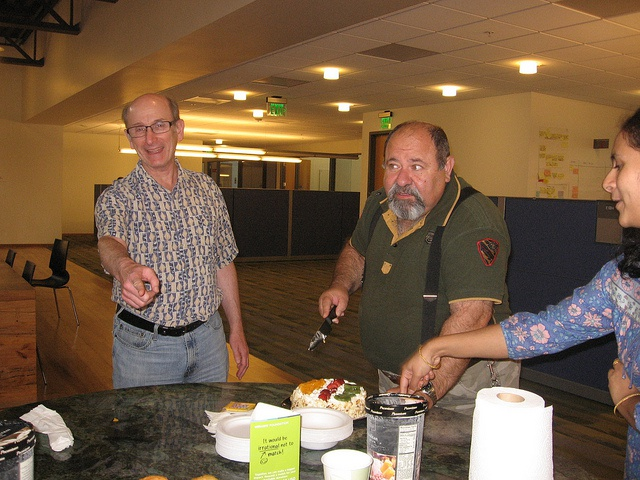Describe the objects in this image and their specific colors. I can see people in black and brown tones, people in black, gray, brown, darkgray, and tan tones, dining table in black and gray tones, people in black, gray, tan, salmon, and darkgray tones, and cake in black, ivory, tan, and olive tones in this image. 